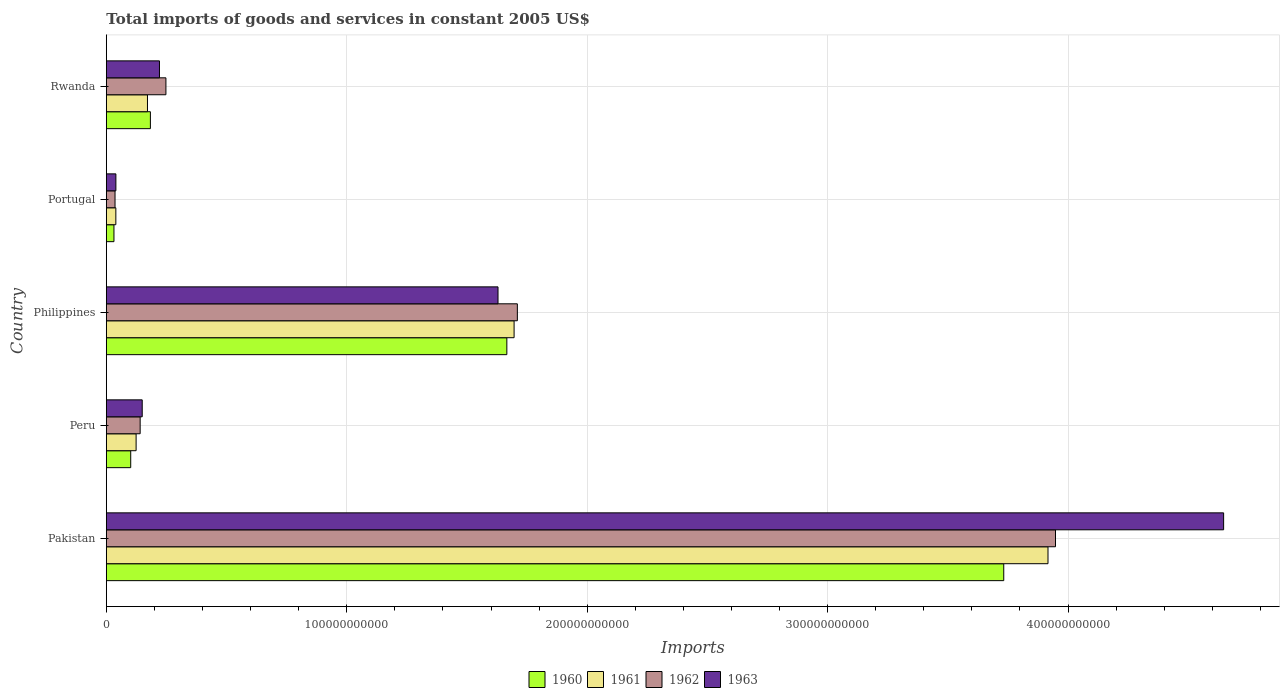How many different coloured bars are there?
Your answer should be compact. 4. Are the number of bars per tick equal to the number of legend labels?
Make the answer very short. Yes. Are the number of bars on each tick of the Y-axis equal?
Ensure brevity in your answer.  Yes. What is the label of the 4th group of bars from the top?
Provide a short and direct response. Peru. What is the total imports of goods and services in 1960 in Portugal?
Your answer should be very brief. 3.17e+09. Across all countries, what is the maximum total imports of goods and services in 1962?
Make the answer very short. 3.95e+11. Across all countries, what is the minimum total imports of goods and services in 1961?
Your response must be concise. 3.96e+09. In which country was the total imports of goods and services in 1960 maximum?
Your answer should be compact. Pakistan. In which country was the total imports of goods and services in 1961 minimum?
Your answer should be very brief. Portugal. What is the total total imports of goods and services in 1960 in the graph?
Offer a very short reply. 5.71e+11. What is the difference between the total imports of goods and services in 1962 in Peru and that in Portugal?
Your answer should be compact. 1.04e+1. What is the difference between the total imports of goods and services in 1962 in Rwanda and the total imports of goods and services in 1963 in Portugal?
Your response must be concise. 2.08e+1. What is the average total imports of goods and services in 1961 per country?
Ensure brevity in your answer.  1.19e+11. What is the difference between the total imports of goods and services in 1963 and total imports of goods and services in 1960 in Portugal?
Keep it short and to the point. 8.09e+08. What is the ratio of the total imports of goods and services in 1962 in Pakistan to that in Portugal?
Your answer should be very brief. 109.08. Is the total imports of goods and services in 1962 in Philippines less than that in Rwanda?
Provide a short and direct response. No. What is the difference between the highest and the second highest total imports of goods and services in 1962?
Provide a succinct answer. 2.24e+11. What is the difference between the highest and the lowest total imports of goods and services in 1963?
Your answer should be very brief. 4.61e+11. In how many countries, is the total imports of goods and services in 1961 greater than the average total imports of goods and services in 1961 taken over all countries?
Your answer should be compact. 2. Is it the case that in every country, the sum of the total imports of goods and services in 1961 and total imports of goods and services in 1963 is greater than the sum of total imports of goods and services in 1962 and total imports of goods and services in 1960?
Provide a succinct answer. No. What does the 3rd bar from the top in Philippines represents?
Your answer should be very brief. 1961. What does the 1st bar from the bottom in Rwanda represents?
Your response must be concise. 1960. Are all the bars in the graph horizontal?
Ensure brevity in your answer.  Yes. How many countries are there in the graph?
Offer a terse response. 5. What is the difference between two consecutive major ticks on the X-axis?
Give a very brief answer. 1.00e+11. Are the values on the major ticks of X-axis written in scientific E-notation?
Ensure brevity in your answer.  No. Where does the legend appear in the graph?
Make the answer very short. Bottom center. How many legend labels are there?
Provide a succinct answer. 4. What is the title of the graph?
Your response must be concise. Total imports of goods and services in constant 2005 US$. Does "1962" appear as one of the legend labels in the graph?
Give a very brief answer. Yes. What is the label or title of the X-axis?
Give a very brief answer. Imports. What is the label or title of the Y-axis?
Give a very brief answer. Country. What is the Imports of 1960 in Pakistan?
Keep it short and to the point. 3.73e+11. What is the Imports in 1961 in Pakistan?
Provide a short and direct response. 3.92e+11. What is the Imports in 1962 in Pakistan?
Make the answer very short. 3.95e+11. What is the Imports in 1963 in Pakistan?
Make the answer very short. 4.65e+11. What is the Imports in 1960 in Peru?
Your response must be concise. 1.01e+1. What is the Imports of 1961 in Peru?
Your answer should be compact. 1.24e+1. What is the Imports of 1962 in Peru?
Your answer should be compact. 1.41e+1. What is the Imports in 1963 in Peru?
Offer a terse response. 1.49e+1. What is the Imports of 1960 in Philippines?
Keep it short and to the point. 1.67e+11. What is the Imports in 1961 in Philippines?
Keep it short and to the point. 1.70e+11. What is the Imports in 1962 in Philippines?
Ensure brevity in your answer.  1.71e+11. What is the Imports in 1963 in Philippines?
Offer a very short reply. 1.63e+11. What is the Imports of 1960 in Portugal?
Keep it short and to the point. 3.17e+09. What is the Imports of 1961 in Portugal?
Make the answer very short. 3.96e+09. What is the Imports in 1962 in Portugal?
Your response must be concise. 3.62e+09. What is the Imports of 1963 in Portugal?
Your answer should be very brief. 3.98e+09. What is the Imports of 1960 in Rwanda?
Offer a very short reply. 1.83e+1. What is the Imports of 1961 in Rwanda?
Provide a succinct answer. 1.71e+1. What is the Imports of 1962 in Rwanda?
Provide a short and direct response. 2.48e+1. What is the Imports of 1963 in Rwanda?
Offer a very short reply. 2.21e+1. Across all countries, what is the maximum Imports in 1960?
Make the answer very short. 3.73e+11. Across all countries, what is the maximum Imports of 1961?
Give a very brief answer. 3.92e+11. Across all countries, what is the maximum Imports in 1962?
Your response must be concise. 3.95e+11. Across all countries, what is the maximum Imports of 1963?
Your answer should be very brief. 4.65e+11. Across all countries, what is the minimum Imports in 1960?
Offer a terse response. 3.17e+09. Across all countries, what is the minimum Imports in 1961?
Provide a succinct answer. 3.96e+09. Across all countries, what is the minimum Imports of 1962?
Your response must be concise. 3.62e+09. Across all countries, what is the minimum Imports in 1963?
Make the answer very short. 3.98e+09. What is the total Imports of 1960 in the graph?
Your answer should be very brief. 5.71e+11. What is the total Imports in 1961 in the graph?
Give a very brief answer. 5.95e+11. What is the total Imports in 1962 in the graph?
Ensure brevity in your answer.  6.08e+11. What is the total Imports in 1963 in the graph?
Give a very brief answer. 6.69e+11. What is the difference between the Imports in 1960 in Pakistan and that in Peru?
Your answer should be compact. 3.63e+11. What is the difference between the Imports of 1961 in Pakistan and that in Peru?
Offer a very short reply. 3.79e+11. What is the difference between the Imports in 1962 in Pakistan and that in Peru?
Ensure brevity in your answer.  3.81e+11. What is the difference between the Imports in 1963 in Pakistan and that in Peru?
Provide a short and direct response. 4.50e+11. What is the difference between the Imports in 1960 in Pakistan and that in Philippines?
Provide a succinct answer. 2.07e+11. What is the difference between the Imports in 1961 in Pakistan and that in Philippines?
Your answer should be compact. 2.22e+11. What is the difference between the Imports in 1962 in Pakistan and that in Philippines?
Make the answer very short. 2.24e+11. What is the difference between the Imports in 1963 in Pakistan and that in Philippines?
Ensure brevity in your answer.  3.02e+11. What is the difference between the Imports in 1960 in Pakistan and that in Portugal?
Ensure brevity in your answer.  3.70e+11. What is the difference between the Imports in 1961 in Pakistan and that in Portugal?
Offer a terse response. 3.88e+11. What is the difference between the Imports in 1962 in Pakistan and that in Portugal?
Provide a short and direct response. 3.91e+11. What is the difference between the Imports of 1963 in Pakistan and that in Portugal?
Your answer should be very brief. 4.61e+11. What is the difference between the Imports in 1960 in Pakistan and that in Rwanda?
Your response must be concise. 3.55e+11. What is the difference between the Imports in 1961 in Pakistan and that in Rwanda?
Make the answer very short. 3.75e+11. What is the difference between the Imports in 1962 in Pakistan and that in Rwanda?
Your answer should be very brief. 3.70e+11. What is the difference between the Imports of 1963 in Pakistan and that in Rwanda?
Give a very brief answer. 4.43e+11. What is the difference between the Imports in 1960 in Peru and that in Philippines?
Offer a terse response. -1.56e+11. What is the difference between the Imports in 1961 in Peru and that in Philippines?
Provide a short and direct response. -1.57e+11. What is the difference between the Imports of 1962 in Peru and that in Philippines?
Offer a very short reply. -1.57e+11. What is the difference between the Imports of 1963 in Peru and that in Philippines?
Offer a terse response. -1.48e+11. What is the difference between the Imports of 1960 in Peru and that in Portugal?
Keep it short and to the point. 6.98e+09. What is the difference between the Imports in 1961 in Peru and that in Portugal?
Offer a very short reply. 8.43e+09. What is the difference between the Imports in 1962 in Peru and that in Portugal?
Your answer should be compact. 1.04e+1. What is the difference between the Imports of 1963 in Peru and that in Portugal?
Give a very brief answer. 1.10e+1. What is the difference between the Imports in 1960 in Peru and that in Rwanda?
Provide a short and direct response. -8.18e+09. What is the difference between the Imports in 1961 in Peru and that in Rwanda?
Provide a succinct answer. -4.72e+09. What is the difference between the Imports of 1962 in Peru and that in Rwanda?
Your answer should be very brief. -1.07e+1. What is the difference between the Imports of 1963 in Peru and that in Rwanda?
Your response must be concise. -7.17e+09. What is the difference between the Imports of 1960 in Philippines and that in Portugal?
Offer a very short reply. 1.63e+11. What is the difference between the Imports in 1961 in Philippines and that in Portugal?
Offer a very short reply. 1.66e+11. What is the difference between the Imports of 1962 in Philippines and that in Portugal?
Offer a terse response. 1.67e+11. What is the difference between the Imports of 1963 in Philippines and that in Portugal?
Your response must be concise. 1.59e+11. What is the difference between the Imports of 1960 in Philippines and that in Rwanda?
Ensure brevity in your answer.  1.48e+11. What is the difference between the Imports of 1961 in Philippines and that in Rwanda?
Keep it short and to the point. 1.52e+11. What is the difference between the Imports in 1962 in Philippines and that in Rwanda?
Your response must be concise. 1.46e+11. What is the difference between the Imports of 1963 in Philippines and that in Rwanda?
Your answer should be compact. 1.41e+11. What is the difference between the Imports of 1960 in Portugal and that in Rwanda?
Keep it short and to the point. -1.52e+1. What is the difference between the Imports of 1961 in Portugal and that in Rwanda?
Offer a very short reply. -1.32e+1. What is the difference between the Imports of 1962 in Portugal and that in Rwanda?
Provide a succinct answer. -2.12e+1. What is the difference between the Imports of 1963 in Portugal and that in Rwanda?
Offer a very short reply. -1.81e+1. What is the difference between the Imports in 1960 in Pakistan and the Imports in 1961 in Peru?
Provide a succinct answer. 3.61e+11. What is the difference between the Imports of 1960 in Pakistan and the Imports of 1962 in Peru?
Give a very brief answer. 3.59e+11. What is the difference between the Imports in 1960 in Pakistan and the Imports in 1963 in Peru?
Your response must be concise. 3.58e+11. What is the difference between the Imports in 1961 in Pakistan and the Imports in 1962 in Peru?
Your response must be concise. 3.78e+11. What is the difference between the Imports in 1961 in Pakistan and the Imports in 1963 in Peru?
Provide a succinct answer. 3.77e+11. What is the difference between the Imports of 1962 in Pakistan and the Imports of 1963 in Peru?
Keep it short and to the point. 3.80e+11. What is the difference between the Imports in 1960 in Pakistan and the Imports in 1961 in Philippines?
Keep it short and to the point. 2.04e+11. What is the difference between the Imports in 1960 in Pakistan and the Imports in 1962 in Philippines?
Make the answer very short. 2.02e+11. What is the difference between the Imports of 1960 in Pakistan and the Imports of 1963 in Philippines?
Keep it short and to the point. 2.10e+11. What is the difference between the Imports of 1961 in Pakistan and the Imports of 1962 in Philippines?
Provide a short and direct response. 2.21e+11. What is the difference between the Imports in 1961 in Pakistan and the Imports in 1963 in Philippines?
Provide a succinct answer. 2.29e+11. What is the difference between the Imports of 1962 in Pakistan and the Imports of 1963 in Philippines?
Ensure brevity in your answer.  2.32e+11. What is the difference between the Imports in 1960 in Pakistan and the Imports in 1961 in Portugal?
Your response must be concise. 3.69e+11. What is the difference between the Imports of 1960 in Pakistan and the Imports of 1962 in Portugal?
Offer a terse response. 3.70e+11. What is the difference between the Imports in 1960 in Pakistan and the Imports in 1963 in Portugal?
Give a very brief answer. 3.69e+11. What is the difference between the Imports in 1961 in Pakistan and the Imports in 1962 in Portugal?
Offer a very short reply. 3.88e+11. What is the difference between the Imports in 1961 in Pakistan and the Imports in 1963 in Portugal?
Your response must be concise. 3.88e+11. What is the difference between the Imports in 1962 in Pakistan and the Imports in 1963 in Portugal?
Offer a very short reply. 3.91e+11. What is the difference between the Imports in 1960 in Pakistan and the Imports in 1961 in Rwanda?
Your answer should be very brief. 3.56e+11. What is the difference between the Imports in 1960 in Pakistan and the Imports in 1962 in Rwanda?
Ensure brevity in your answer.  3.48e+11. What is the difference between the Imports of 1960 in Pakistan and the Imports of 1963 in Rwanda?
Ensure brevity in your answer.  3.51e+11. What is the difference between the Imports of 1961 in Pakistan and the Imports of 1962 in Rwanda?
Your response must be concise. 3.67e+11. What is the difference between the Imports of 1961 in Pakistan and the Imports of 1963 in Rwanda?
Make the answer very short. 3.70e+11. What is the difference between the Imports of 1962 in Pakistan and the Imports of 1963 in Rwanda?
Make the answer very short. 3.73e+11. What is the difference between the Imports in 1960 in Peru and the Imports in 1961 in Philippines?
Provide a short and direct response. -1.59e+11. What is the difference between the Imports of 1960 in Peru and the Imports of 1962 in Philippines?
Keep it short and to the point. -1.61e+11. What is the difference between the Imports in 1960 in Peru and the Imports in 1963 in Philippines?
Provide a succinct answer. -1.53e+11. What is the difference between the Imports of 1961 in Peru and the Imports of 1962 in Philippines?
Make the answer very short. -1.59e+11. What is the difference between the Imports of 1961 in Peru and the Imports of 1963 in Philippines?
Ensure brevity in your answer.  -1.51e+11. What is the difference between the Imports of 1962 in Peru and the Imports of 1963 in Philippines?
Make the answer very short. -1.49e+11. What is the difference between the Imports of 1960 in Peru and the Imports of 1961 in Portugal?
Give a very brief answer. 6.19e+09. What is the difference between the Imports in 1960 in Peru and the Imports in 1962 in Portugal?
Your response must be concise. 6.53e+09. What is the difference between the Imports in 1960 in Peru and the Imports in 1963 in Portugal?
Provide a succinct answer. 6.17e+09. What is the difference between the Imports of 1961 in Peru and the Imports of 1962 in Portugal?
Offer a terse response. 8.77e+09. What is the difference between the Imports in 1961 in Peru and the Imports in 1963 in Portugal?
Your response must be concise. 8.41e+09. What is the difference between the Imports of 1962 in Peru and the Imports of 1963 in Portugal?
Provide a succinct answer. 1.01e+1. What is the difference between the Imports of 1960 in Peru and the Imports of 1961 in Rwanda?
Offer a very short reply. -6.96e+09. What is the difference between the Imports in 1960 in Peru and the Imports in 1962 in Rwanda?
Your answer should be very brief. -1.46e+1. What is the difference between the Imports of 1960 in Peru and the Imports of 1963 in Rwanda?
Your response must be concise. -1.20e+1. What is the difference between the Imports in 1961 in Peru and the Imports in 1962 in Rwanda?
Provide a succinct answer. -1.24e+1. What is the difference between the Imports of 1961 in Peru and the Imports of 1963 in Rwanda?
Ensure brevity in your answer.  -9.71e+09. What is the difference between the Imports in 1962 in Peru and the Imports in 1963 in Rwanda?
Your response must be concise. -8.03e+09. What is the difference between the Imports of 1960 in Philippines and the Imports of 1961 in Portugal?
Ensure brevity in your answer.  1.63e+11. What is the difference between the Imports in 1960 in Philippines and the Imports in 1962 in Portugal?
Offer a terse response. 1.63e+11. What is the difference between the Imports in 1960 in Philippines and the Imports in 1963 in Portugal?
Provide a short and direct response. 1.63e+11. What is the difference between the Imports of 1961 in Philippines and the Imports of 1962 in Portugal?
Make the answer very short. 1.66e+11. What is the difference between the Imports of 1961 in Philippines and the Imports of 1963 in Portugal?
Provide a short and direct response. 1.66e+11. What is the difference between the Imports in 1962 in Philippines and the Imports in 1963 in Portugal?
Your answer should be compact. 1.67e+11. What is the difference between the Imports in 1960 in Philippines and the Imports in 1961 in Rwanda?
Provide a succinct answer. 1.49e+11. What is the difference between the Imports in 1960 in Philippines and the Imports in 1962 in Rwanda?
Make the answer very short. 1.42e+11. What is the difference between the Imports of 1960 in Philippines and the Imports of 1963 in Rwanda?
Your answer should be compact. 1.44e+11. What is the difference between the Imports of 1961 in Philippines and the Imports of 1962 in Rwanda?
Make the answer very short. 1.45e+11. What is the difference between the Imports in 1961 in Philippines and the Imports in 1963 in Rwanda?
Provide a succinct answer. 1.47e+11. What is the difference between the Imports of 1962 in Philippines and the Imports of 1963 in Rwanda?
Give a very brief answer. 1.49e+11. What is the difference between the Imports of 1960 in Portugal and the Imports of 1961 in Rwanda?
Provide a short and direct response. -1.39e+1. What is the difference between the Imports in 1960 in Portugal and the Imports in 1962 in Rwanda?
Provide a short and direct response. -2.16e+1. What is the difference between the Imports of 1960 in Portugal and the Imports of 1963 in Rwanda?
Provide a short and direct response. -1.89e+1. What is the difference between the Imports of 1961 in Portugal and the Imports of 1962 in Rwanda?
Offer a very short reply. -2.08e+1. What is the difference between the Imports in 1961 in Portugal and the Imports in 1963 in Rwanda?
Ensure brevity in your answer.  -1.81e+1. What is the difference between the Imports of 1962 in Portugal and the Imports of 1963 in Rwanda?
Your response must be concise. -1.85e+1. What is the average Imports of 1960 per country?
Ensure brevity in your answer.  1.14e+11. What is the average Imports of 1961 per country?
Make the answer very short. 1.19e+11. What is the average Imports of 1962 per country?
Offer a terse response. 1.22e+11. What is the average Imports of 1963 per country?
Make the answer very short. 1.34e+11. What is the difference between the Imports in 1960 and Imports in 1961 in Pakistan?
Give a very brief answer. -1.84e+1. What is the difference between the Imports in 1960 and Imports in 1962 in Pakistan?
Keep it short and to the point. -2.15e+1. What is the difference between the Imports in 1960 and Imports in 1963 in Pakistan?
Provide a succinct answer. -9.14e+1. What is the difference between the Imports of 1961 and Imports of 1962 in Pakistan?
Ensure brevity in your answer.  -3.12e+09. What is the difference between the Imports of 1961 and Imports of 1963 in Pakistan?
Your answer should be very brief. -7.30e+1. What is the difference between the Imports of 1962 and Imports of 1963 in Pakistan?
Keep it short and to the point. -6.99e+1. What is the difference between the Imports in 1960 and Imports in 1961 in Peru?
Provide a short and direct response. -2.24e+09. What is the difference between the Imports of 1960 and Imports of 1962 in Peru?
Offer a terse response. -3.92e+09. What is the difference between the Imports of 1960 and Imports of 1963 in Peru?
Provide a short and direct response. -4.78e+09. What is the difference between the Imports in 1961 and Imports in 1962 in Peru?
Provide a succinct answer. -1.68e+09. What is the difference between the Imports of 1961 and Imports of 1963 in Peru?
Offer a very short reply. -2.54e+09. What is the difference between the Imports of 1962 and Imports of 1963 in Peru?
Give a very brief answer. -8.62e+08. What is the difference between the Imports of 1960 and Imports of 1961 in Philippines?
Your response must be concise. -3.01e+09. What is the difference between the Imports of 1960 and Imports of 1962 in Philippines?
Ensure brevity in your answer.  -4.37e+09. What is the difference between the Imports in 1960 and Imports in 1963 in Philippines?
Provide a short and direct response. 3.68e+09. What is the difference between the Imports in 1961 and Imports in 1962 in Philippines?
Your answer should be compact. -1.36e+09. What is the difference between the Imports in 1961 and Imports in 1963 in Philippines?
Give a very brief answer. 6.69e+09. What is the difference between the Imports of 1962 and Imports of 1963 in Philippines?
Provide a succinct answer. 8.04e+09. What is the difference between the Imports of 1960 and Imports of 1961 in Portugal?
Keep it short and to the point. -7.89e+08. What is the difference between the Imports in 1960 and Imports in 1962 in Portugal?
Offer a very short reply. -4.52e+08. What is the difference between the Imports in 1960 and Imports in 1963 in Portugal?
Provide a short and direct response. -8.09e+08. What is the difference between the Imports in 1961 and Imports in 1962 in Portugal?
Give a very brief answer. 3.37e+08. What is the difference between the Imports in 1961 and Imports in 1963 in Portugal?
Provide a succinct answer. -2.01e+07. What is the difference between the Imports of 1962 and Imports of 1963 in Portugal?
Make the answer very short. -3.57e+08. What is the difference between the Imports of 1960 and Imports of 1961 in Rwanda?
Offer a very short reply. 1.22e+09. What is the difference between the Imports in 1960 and Imports in 1962 in Rwanda?
Ensure brevity in your answer.  -6.46e+09. What is the difference between the Imports of 1960 and Imports of 1963 in Rwanda?
Your answer should be compact. -3.77e+09. What is the difference between the Imports of 1961 and Imports of 1962 in Rwanda?
Give a very brief answer. -7.68e+09. What is the difference between the Imports of 1961 and Imports of 1963 in Rwanda?
Provide a succinct answer. -4.99e+09. What is the difference between the Imports in 1962 and Imports in 1963 in Rwanda?
Provide a short and direct response. 2.68e+09. What is the ratio of the Imports of 1960 in Pakistan to that in Peru?
Your answer should be compact. 36.79. What is the ratio of the Imports of 1961 in Pakistan to that in Peru?
Keep it short and to the point. 31.62. What is the ratio of the Imports of 1962 in Pakistan to that in Peru?
Your answer should be compact. 28.07. What is the ratio of the Imports in 1963 in Pakistan to that in Peru?
Offer a very short reply. 31.13. What is the ratio of the Imports in 1960 in Pakistan to that in Philippines?
Offer a very short reply. 2.24. What is the ratio of the Imports of 1961 in Pakistan to that in Philippines?
Make the answer very short. 2.31. What is the ratio of the Imports of 1962 in Pakistan to that in Philippines?
Your answer should be compact. 2.31. What is the ratio of the Imports in 1963 in Pakistan to that in Philippines?
Your answer should be very brief. 2.85. What is the ratio of the Imports of 1960 in Pakistan to that in Portugal?
Offer a very short reply. 117.86. What is the ratio of the Imports in 1961 in Pakistan to that in Portugal?
Provide a short and direct response. 99. What is the ratio of the Imports of 1962 in Pakistan to that in Portugal?
Keep it short and to the point. 109.08. What is the ratio of the Imports of 1963 in Pakistan to that in Portugal?
Your response must be concise. 116.87. What is the ratio of the Imports in 1960 in Pakistan to that in Rwanda?
Offer a very short reply. 20.37. What is the ratio of the Imports of 1961 in Pakistan to that in Rwanda?
Your response must be concise. 22.9. What is the ratio of the Imports in 1962 in Pakistan to that in Rwanda?
Your answer should be compact. 15.93. What is the ratio of the Imports of 1963 in Pakistan to that in Rwanda?
Ensure brevity in your answer.  21.03. What is the ratio of the Imports of 1960 in Peru to that in Philippines?
Offer a very short reply. 0.06. What is the ratio of the Imports in 1961 in Peru to that in Philippines?
Provide a short and direct response. 0.07. What is the ratio of the Imports of 1962 in Peru to that in Philippines?
Your answer should be compact. 0.08. What is the ratio of the Imports in 1963 in Peru to that in Philippines?
Your response must be concise. 0.09. What is the ratio of the Imports of 1960 in Peru to that in Portugal?
Offer a very short reply. 3.2. What is the ratio of the Imports in 1961 in Peru to that in Portugal?
Your answer should be compact. 3.13. What is the ratio of the Imports in 1962 in Peru to that in Portugal?
Provide a succinct answer. 3.89. What is the ratio of the Imports of 1963 in Peru to that in Portugal?
Give a very brief answer. 3.75. What is the ratio of the Imports in 1960 in Peru to that in Rwanda?
Offer a very short reply. 0.55. What is the ratio of the Imports in 1961 in Peru to that in Rwanda?
Your response must be concise. 0.72. What is the ratio of the Imports of 1962 in Peru to that in Rwanda?
Your answer should be compact. 0.57. What is the ratio of the Imports in 1963 in Peru to that in Rwanda?
Your answer should be compact. 0.68. What is the ratio of the Imports in 1960 in Philippines to that in Portugal?
Provide a succinct answer. 52.6. What is the ratio of the Imports of 1961 in Philippines to that in Portugal?
Your answer should be compact. 42.87. What is the ratio of the Imports of 1962 in Philippines to that in Portugal?
Your answer should be compact. 47.23. What is the ratio of the Imports of 1963 in Philippines to that in Portugal?
Ensure brevity in your answer.  40.97. What is the ratio of the Imports of 1960 in Philippines to that in Rwanda?
Offer a very short reply. 9.09. What is the ratio of the Imports of 1961 in Philippines to that in Rwanda?
Provide a succinct answer. 9.91. What is the ratio of the Imports of 1962 in Philippines to that in Rwanda?
Ensure brevity in your answer.  6.9. What is the ratio of the Imports of 1963 in Philippines to that in Rwanda?
Your response must be concise. 7.37. What is the ratio of the Imports in 1960 in Portugal to that in Rwanda?
Give a very brief answer. 0.17. What is the ratio of the Imports in 1961 in Portugal to that in Rwanda?
Offer a very short reply. 0.23. What is the ratio of the Imports of 1962 in Portugal to that in Rwanda?
Offer a very short reply. 0.15. What is the ratio of the Imports in 1963 in Portugal to that in Rwanda?
Give a very brief answer. 0.18. What is the difference between the highest and the second highest Imports in 1960?
Make the answer very short. 2.07e+11. What is the difference between the highest and the second highest Imports of 1961?
Give a very brief answer. 2.22e+11. What is the difference between the highest and the second highest Imports of 1962?
Make the answer very short. 2.24e+11. What is the difference between the highest and the second highest Imports in 1963?
Provide a succinct answer. 3.02e+11. What is the difference between the highest and the lowest Imports of 1960?
Make the answer very short. 3.70e+11. What is the difference between the highest and the lowest Imports of 1961?
Ensure brevity in your answer.  3.88e+11. What is the difference between the highest and the lowest Imports in 1962?
Keep it short and to the point. 3.91e+11. What is the difference between the highest and the lowest Imports in 1963?
Provide a succinct answer. 4.61e+11. 